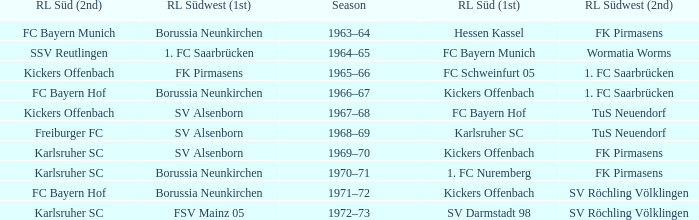Who was RL Süd (1st) when FK Pirmasens was RL Südwest (1st)? FC Schweinfurt 05. 